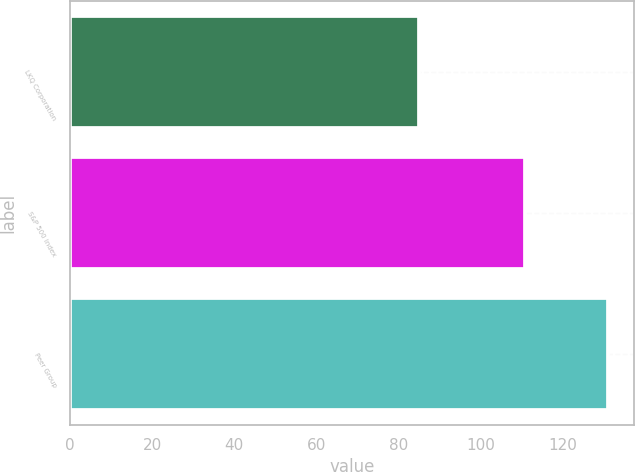<chart> <loc_0><loc_0><loc_500><loc_500><bar_chart><fcel>LKQ Corporation<fcel>S&P 500 Index<fcel>Peer Group<nl><fcel>85<fcel>111<fcel>131<nl></chart> 